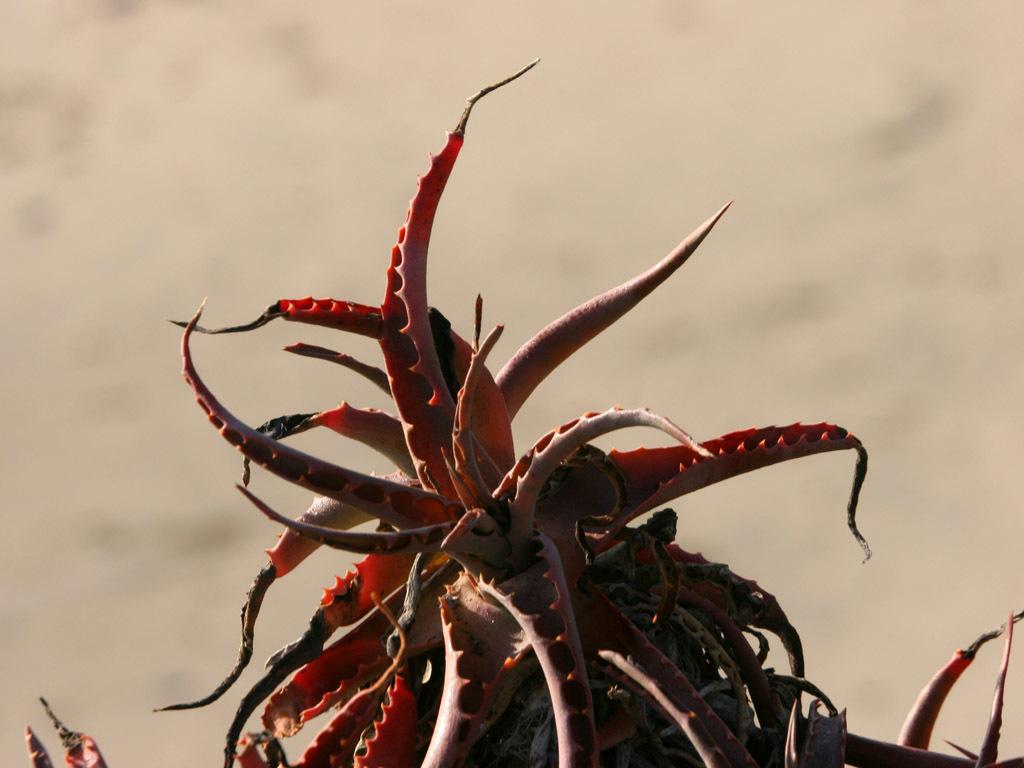Can you describe this image briefly? In this image we can see a kind of a plant which is of a red color. 